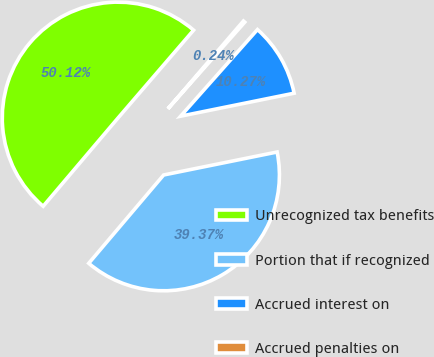Convert chart to OTSL. <chart><loc_0><loc_0><loc_500><loc_500><pie_chart><fcel>Unrecognized tax benefits<fcel>Portion that if recognized<fcel>Accrued interest on<fcel>Accrued penalties on<nl><fcel>50.11%<fcel>39.37%<fcel>10.27%<fcel>0.24%<nl></chart> 